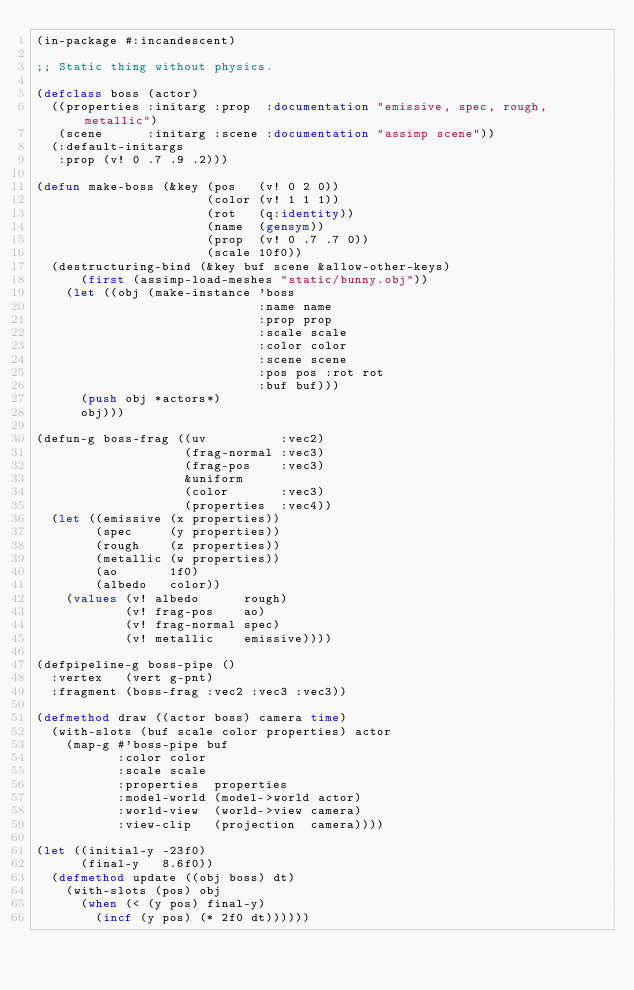Convert code to text. <code><loc_0><loc_0><loc_500><loc_500><_Lisp_>(in-package #:incandescent)

;; Static thing without physics.

(defclass boss (actor)
  ((properties :initarg :prop  :documentation "emissive, spec, rough, metallic")
   (scene      :initarg :scene :documentation "assimp scene"))
  (:default-initargs
   :prop (v! 0 .7 .9 .2)))

(defun make-boss (&key (pos   (v! 0 2 0))
                       (color (v! 1 1 1))
                       (rot   (q:identity))
                       (name  (gensym))
                       (prop  (v! 0 .7 .7 0))
                       (scale 10f0))
  (destructuring-bind (&key buf scene &allow-other-keys)
      (first (assimp-load-meshes "static/bunny.obj"))
    (let ((obj (make-instance 'boss
                              :name name
                              :prop prop
                              :scale scale
                              :color color
                              :scene scene
                              :pos pos :rot rot
                              :buf buf)))
      (push obj *actors*)
      obj)))

(defun-g boss-frag ((uv          :vec2)
                    (frag-normal :vec3)
                    (frag-pos    :vec3)
                    &uniform
                    (color       :vec3)
                    (properties  :vec4))
  (let ((emissive (x properties))
        (spec     (y properties))
        (rough    (z properties))
        (metallic (w properties))
        (ao       1f0)
        (albedo   color))
    (values (v! albedo      rough)
            (v! frag-pos    ao)
            (v! frag-normal spec)
            (v! metallic    emissive))))

(defpipeline-g boss-pipe ()
  :vertex   (vert g-pnt)
  :fragment (boss-frag :vec2 :vec3 :vec3))

(defmethod draw ((actor boss) camera time)
  (with-slots (buf scale color properties) actor
    (map-g #'boss-pipe buf
           :color color
           :scale scale
           :properties  properties
           :model-world (model->world actor)
           :world-view  (world->view camera)
           :view-clip   (projection  camera))))

(let ((initial-y -23f0)
      (final-y   8.6f0))
  (defmethod update ((obj boss) dt)
    (with-slots (pos) obj
      (when (< (y pos) final-y)
        (incf (y pos) (* 2f0 dt))))))
</code> 